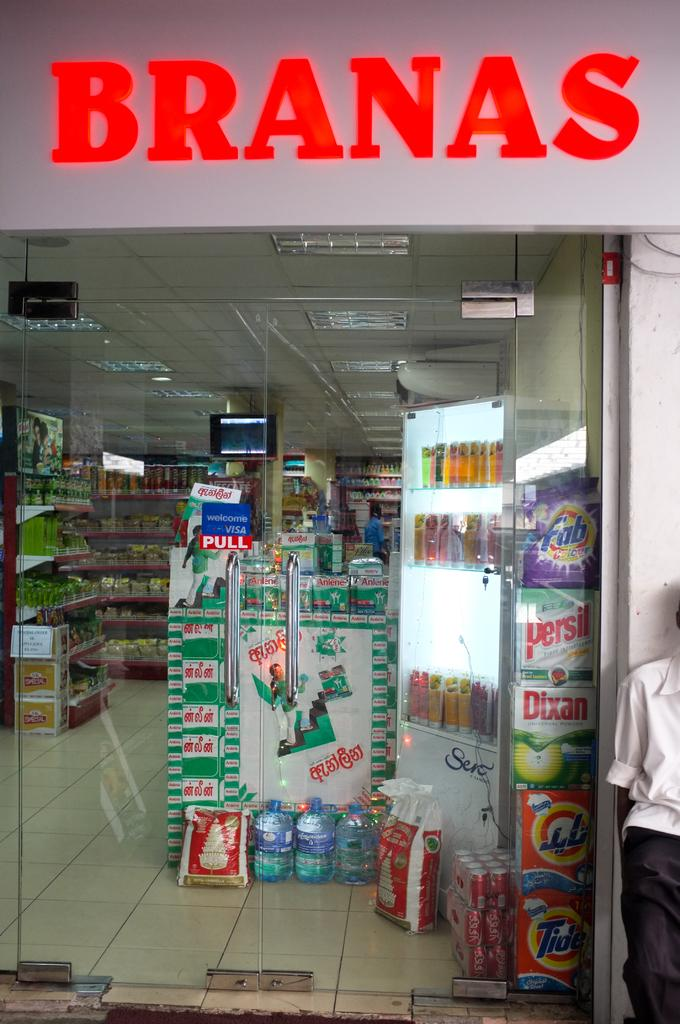What type of establishment is shown in the image? There is a store in the image. What can be seen at the top of the image? There is text visible at the top of the image. What feature is present in the middle of the image? There is a glass door in the middle of the image. What type of hammer is being used by the father in the image? There is no hammer or father present in the image. What is the texture of the store's exterior in the image? The provided facts do not mention the texture of the store's exterior, so it cannot be determined from the image. 